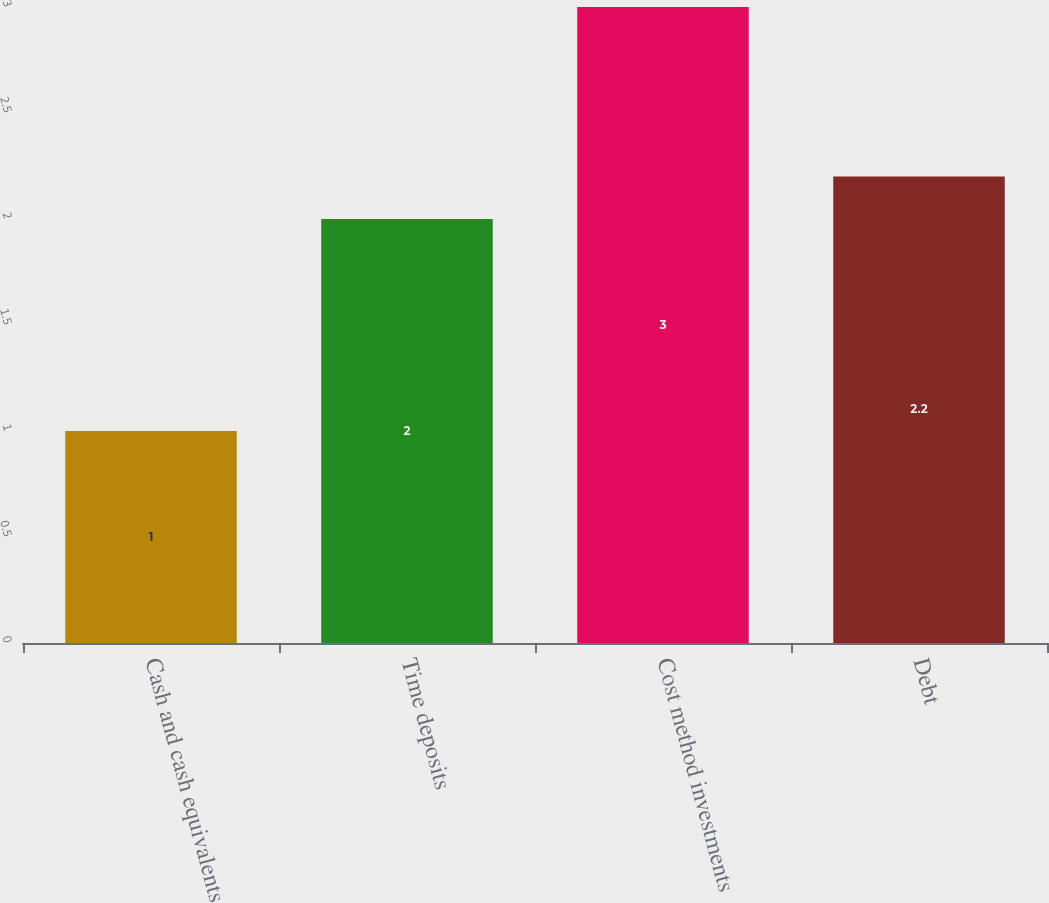Convert chart to OTSL. <chart><loc_0><loc_0><loc_500><loc_500><bar_chart><fcel>Cash and cash equivalents<fcel>Time deposits<fcel>Cost method investments<fcel>Debt<nl><fcel>1<fcel>2<fcel>3<fcel>2.2<nl></chart> 